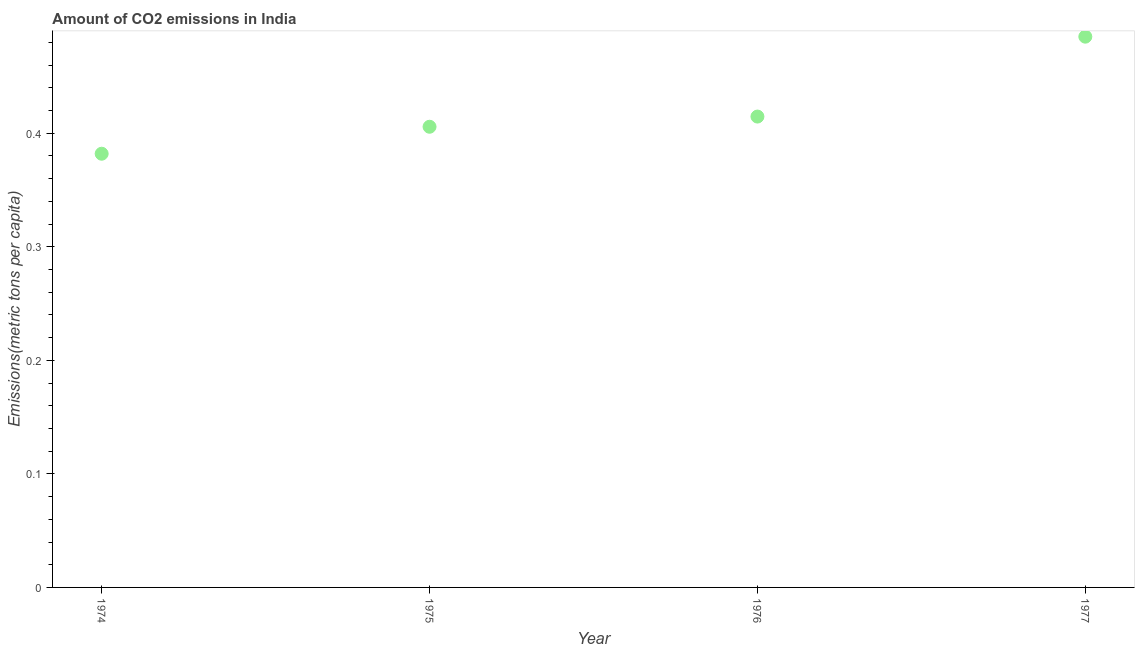What is the amount of co2 emissions in 1975?
Give a very brief answer. 0.41. Across all years, what is the maximum amount of co2 emissions?
Offer a terse response. 0.48. Across all years, what is the minimum amount of co2 emissions?
Your answer should be very brief. 0.38. In which year was the amount of co2 emissions maximum?
Make the answer very short. 1977. In which year was the amount of co2 emissions minimum?
Provide a short and direct response. 1974. What is the sum of the amount of co2 emissions?
Offer a very short reply. 1.69. What is the difference between the amount of co2 emissions in 1974 and 1977?
Your answer should be very brief. -0.1. What is the average amount of co2 emissions per year?
Provide a succinct answer. 0.42. What is the median amount of co2 emissions?
Offer a very short reply. 0.41. What is the ratio of the amount of co2 emissions in 1974 to that in 1975?
Ensure brevity in your answer.  0.94. What is the difference between the highest and the second highest amount of co2 emissions?
Give a very brief answer. 0.07. What is the difference between the highest and the lowest amount of co2 emissions?
Provide a succinct answer. 0.1. In how many years, is the amount of co2 emissions greater than the average amount of co2 emissions taken over all years?
Offer a very short reply. 1. Does the amount of co2 emissions monotonically increase over the years?
Make the answer very short. Yes. What is the difference between two consecutive major ticks on the Y-axis?
Ensure brevity in your answer.  0.1. Are the values on the major ticks of Y-axis written in scientific E-notation?
Give a very brief answer. No. Does the graph contain any zero values?
Offer a very short reply. No. What is the title of the graph?
Make the answer very short. Amount of CO2 emissions in India. What is the label or title of the Y-axis?
Make the answer very short. Emissions(metric tons per capita). What is the Emissions(metric tons per capita) in 1974?
Offer a very short reply. 0.38. What is the Emissions(metric tons per capita) in 1975?
Offer a very short reply. 0.41. What is the Emissions(metric tons per capita) in 1976?
Keep it short and to the point. 0.41. What is the Emissions(metric tons per capita) in 1977?
Offer a very short reply. 0.48. What is the difference between the Emissions(metric tons per capita) in 1974 and 1975?
Your answer should be very brief. -0.02. What is the difference between the Emissions(metric tons per capita) in 1974 and 1976?
Make the answer very short. -0.03. What is the difference between the Emissions(metric tons per capita) in 1974 and 1977?
Offer a very short reply. -0.1. What is the difference between the Emissions(metric tons per capita) in 1975 and 1976?
Keep it short and to the point. -0.01. What is the difference between the Emissions(metric tons per capita) in 1975 and 1977?
Keep it short and to the point. -0.08. What is the difference between the Emissions(metric tons per capita) in 1976 and 1977?
Provide a short and direct response. -0.07. What is the ratio of the Emissions(metric tons per capita) in 1974 to that in 1975?
Offer a terse response. 0.94. What is the ratio of the Emissions(metric tons per capita) in 1974 to that in 1976?
Keep it short and to the point. 0.92. What is the ratio of the Emissions(metric tons per capita) in 1974 to that in 1977?
Your answer should be very brief. 0.79. What is the ratio of the Emissions(metric tons per capita) in 1975 to that in 1977?
Ensure brevity in your answer.  0.84. What is the ratio of the Emissions(metric tons per capita) in 1976 to that in 1977?
Keep it short and to the point. 0.85. 